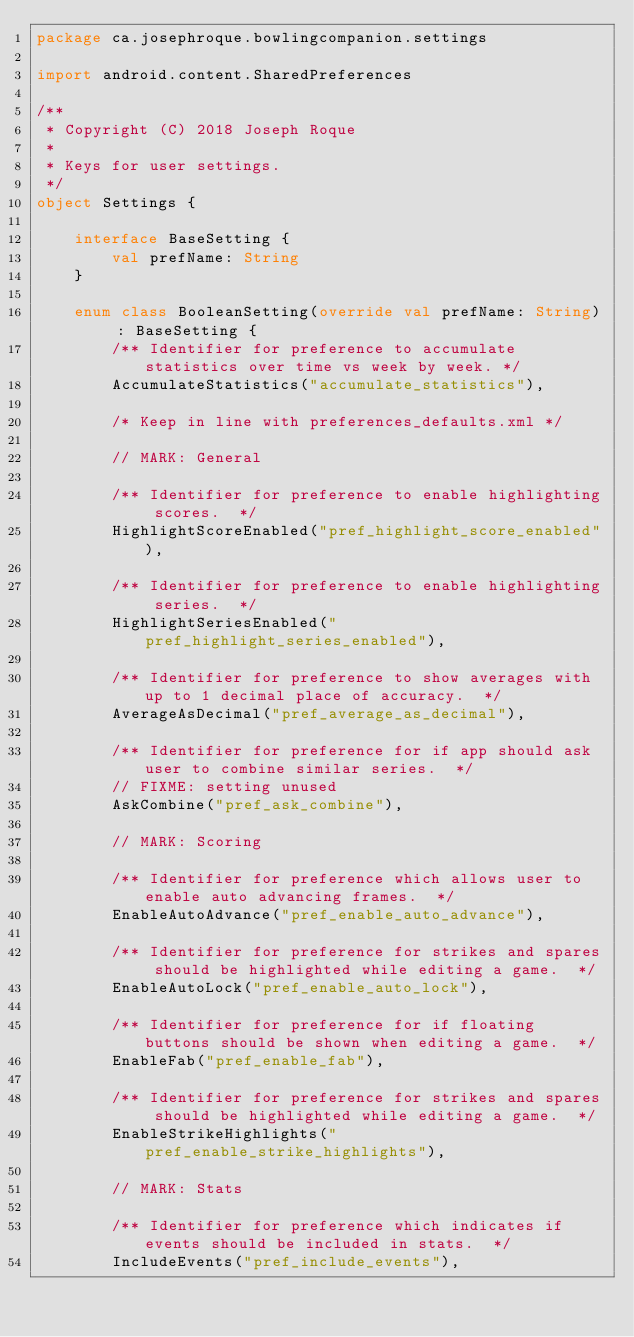Convert code to text. <code><loc_0><loc_0><loc_500><loc_500><_Kotlin_>package ca.josephroque.bowlingcompanion.settings

import android.content.SharedPreferences

/**
 * Copyright (C) 2018 Joseph Roque
 *
 * Keys for user settings.
 */
object Settings {

    interface BaseSetting {
        val prefName: String
    }

    enum class BooleanSetting(override val prefName: String) : BaseSetting {
        /** Identifier for preference to accumulate statistics over time vs week by week. */
        AccumulateStatistics("accumulate_statistics"),

        /* Keep in line with preferences_defaults.xml */

        // MARK: General

        /** Identifier for preference to enable highlighting scores.  */
        HighlightScoreEnabled("pref_highlight_score_enabled"),

        /** Identifier for preference to enable highlighting series.  */
        HighlightSeriesEnabled("pref_highlight_series_enabled"),

        /** Identifier for preference to show averages with up to 1 decimal place of accuracy.  */
        AverageAsDecimal("pref_average_as_decimal"),

        /** Identifier for preference for if app should ask user to combine similar series.  */
        // FIXME: setting unused
        AskCombine("pref_ask_combine"),

        // MARK: Scoring

        /** Identifier for preference which allows user to enable auto advancing frames.  */
        EnableAutoAdvance("pref_enable_auto_advance"),

        /** Identifier for preference for strikes and spares should be highlighted while editing a game.  */
        EnableAutoLock("pref_enable_auto_lock"),

        /** Identifier for preference for if floating buttons should be shown when editing a game.  */
        EnableFab("pref_enable_fab"),

        /** Identifier for preference for strikes and spares should be highlighted while editing a game.  */
        EnableStrikeHighlights("pref_enable_strike_highlights"),

        // MARK: Stats

        /** Identifier for preference which indicates if events should be included in stats.  */
        IncludeEvents("pref_include_events"),
</code> 